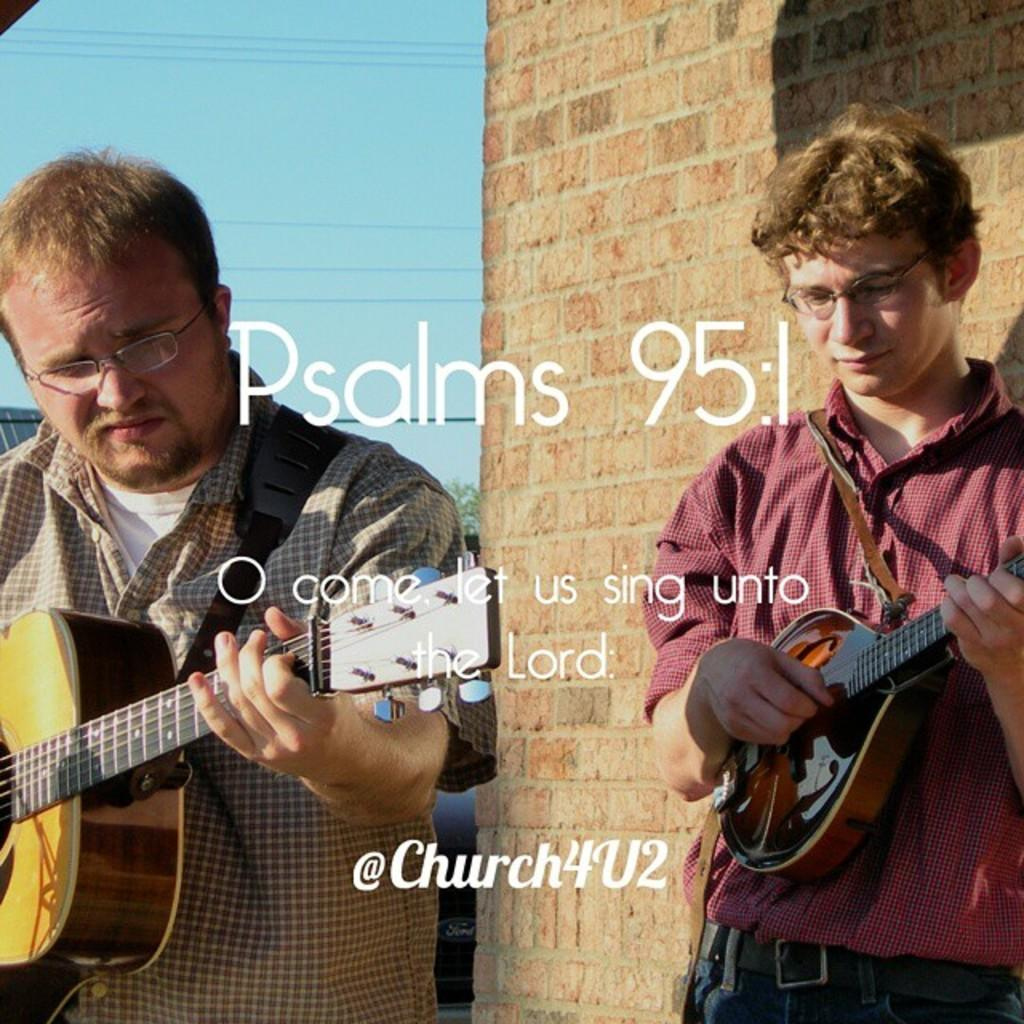How many people are in the image? There are two men in the image. What are the men doing in the image? The men are standing and holding guitars in their hands. What can be seen in the background of the image? There is a wall and the sky visible in the background of the image. What type of calculator is the farmer using in the image? There is no calculator or farmer present in the image. How are the men showing care for the plants in the image? There are no plants present in the image, and the men are holding guitars, not caring for plants. 